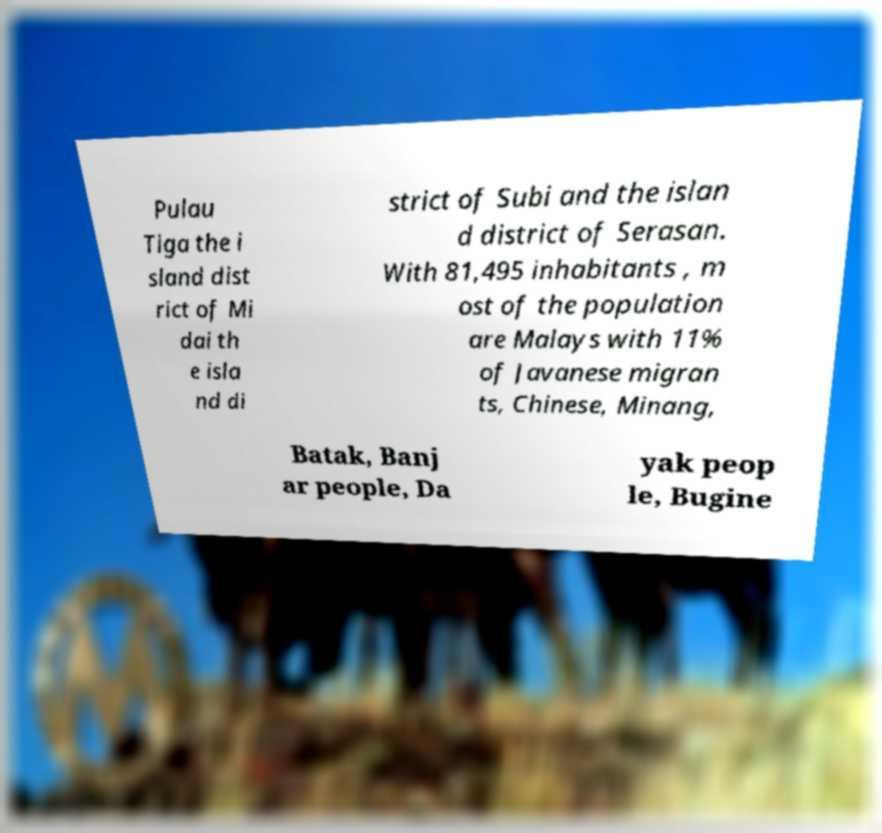Can you accurately transcribe the text from the provided image for me? Pulau Tiga the i sland dist rict of Mi dai th e isla nd di strict of Subi and the islan d district of Serasan. With 81,495 inhabitants , m ost of the population are Malays with 11% of Javanese migran ts, Chinese, Minang, Batak, Banj ar people, Da yak peop le, Bugine 